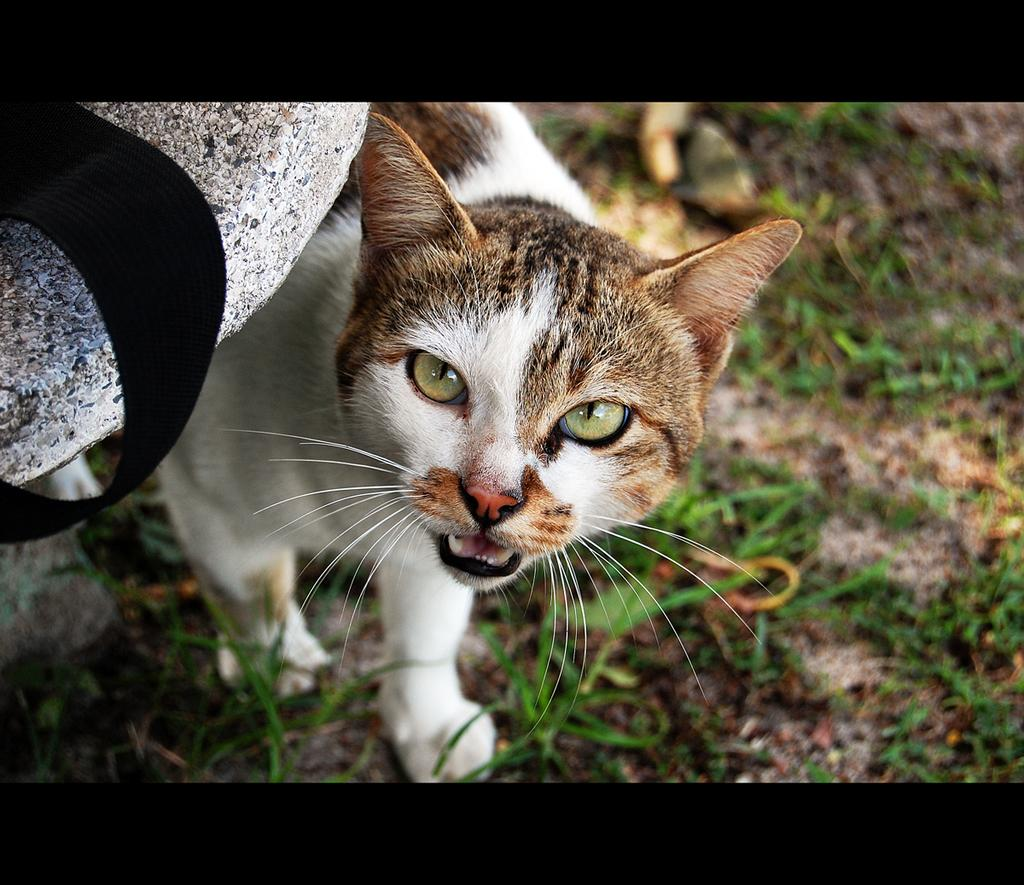What is located in the left corner of the image? There is a stone in the left corner of the image. What is attached to the stone? There is a black strap on the stone. What type of animal is near the stone? There is a cat near the stone. What type of vegetation is on the ground in the image? There is grass on the ground in the image. What type of drug can be seen in the image? There is no drug present in the image. What type of pancake is the cat eating in the image? There is no pancake present in the image, and the cat is not eating anything. 